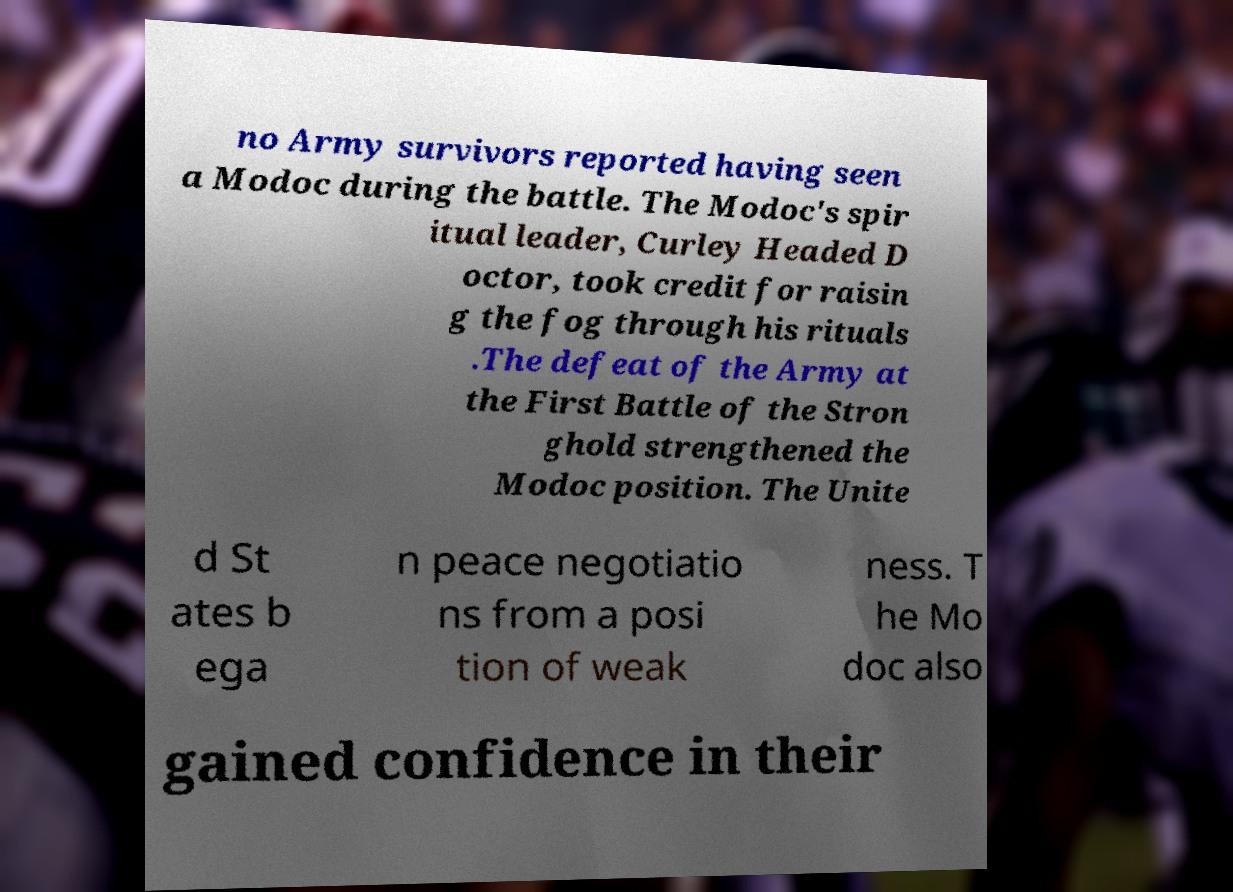Please identify and transcribe the text found in this image. no Army survivors reported having seen a Modoc during the battle. The Modoc's spir itual leader, Curley Headed D octor, took credit for raisin g the fog through his rituals .The defeat of the Army at the First Battle of the Stron ghold strengthened the Modoc position. The Unite d St ates b ega n peace negotiatio ns from a posi tion of weak ness. T he Mo doc also gained confidence in their 